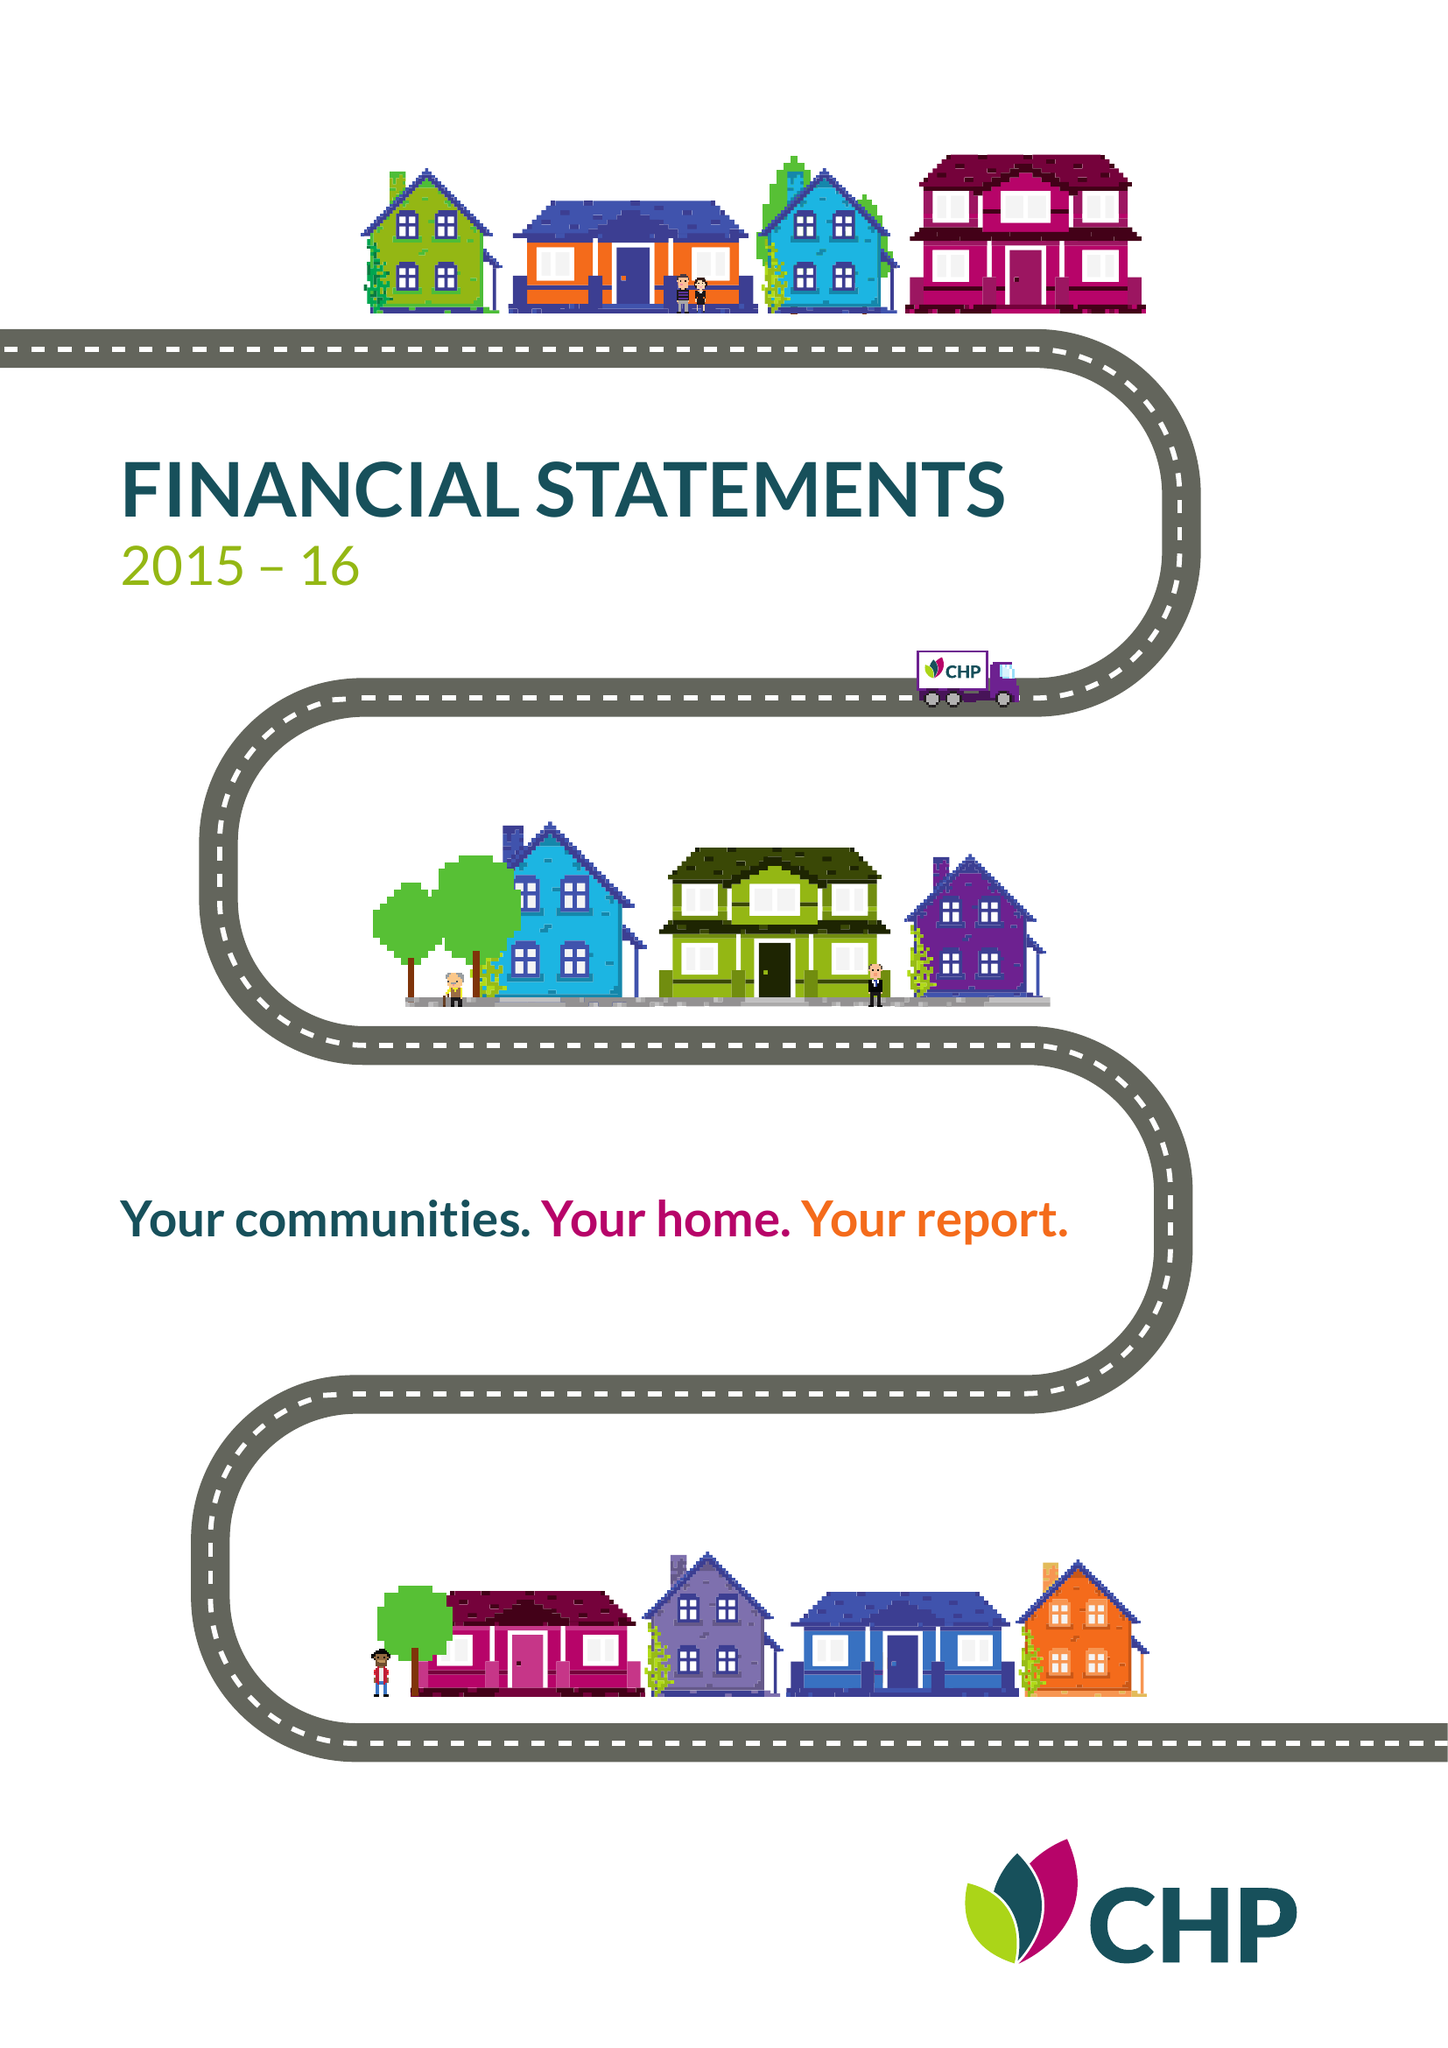What is the value for the charity_number?
Answer the question using a single word or phrase. 1149019 